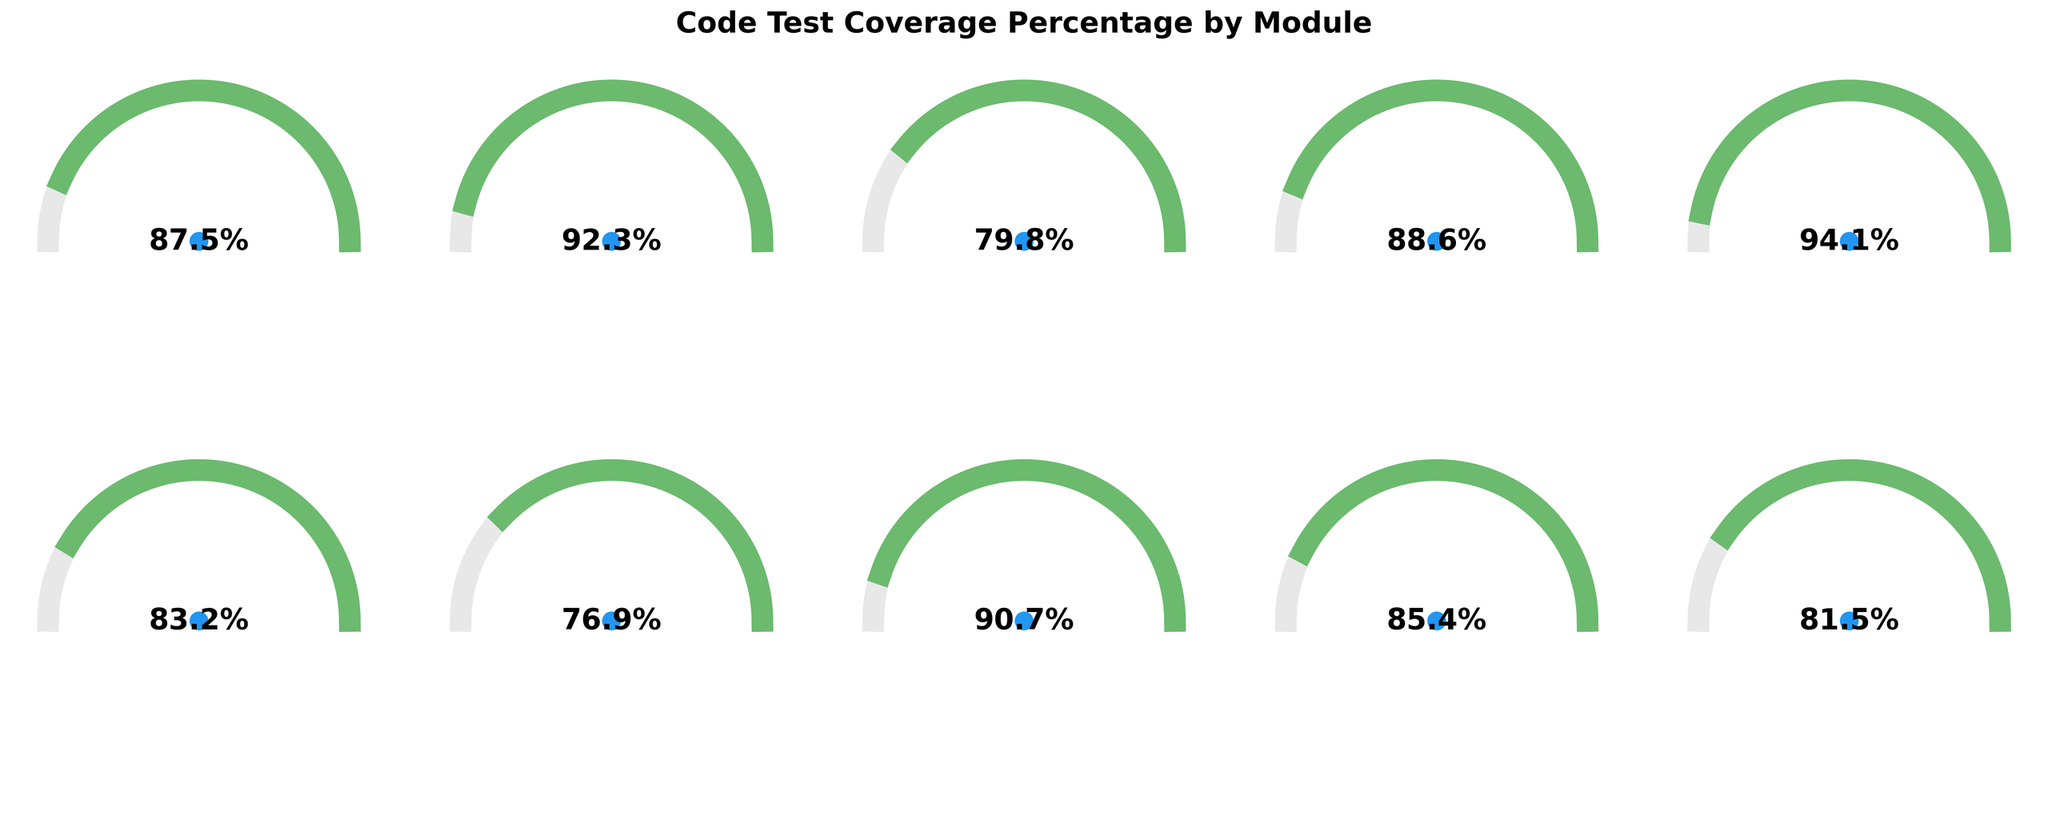What is the test coverage percentage for the Payment Processing module? Locate the "Payment Processing" gauge and read the percentage displayed in the center.
Answer: 94.1% Which module has the lowest test coverage percentage? Compare the percentages displayed at the centers of all gauges.
Answer: Search Functionality How many modules have a test coverage percentage greater than 90%? Count the gauges with percentages greater than 90%.
Answer: 4 What is the average test coverage percentage across all modules? Add up all the coverage percentages and divide by the number of modules. Specifically, (87.5 + 92.3 + 79.8 + 88.6 + 94.1 + 83.2 + 76.9 + 90.7 + 85.4 + 81.5) / 10 = 86%
Answer: 86% Which module shows a coverage percentage closest to 80%? Identify the module with a percentage closest to 80% by comparing the percentages.
Answer: Analytics Engine How much higher is the test coverage for the User Management module compared to the Notification Service module? Subtract the coverage percentage of the Notification Service module from the User Management module. Specifically, 92.3% - 83.2% = 9.1%
Answer: 9.1% Which modules have a coverage percentage between 80% and 90%? List all modules with a percentage within the specified range.
Answer: Authentication, Database Access Layer, Error Handling, Analytics Engine What is the median test coverage percentage across all modules? Sort the coverage percentages and find the middle value: (76.9, 79.8, 81.5, 83.2, 85.4, 87.5, 88.6, 90.7, 92.3, 94.1). With an even number of modules, the median is the average of the 5th and 6th values: (85.4 + 87.5) / 2 = 86.45
Answer: 86.45 Which module's gauge color indicates the highest test coverage percentage? Identify the module with the longest green (dark) segment in the gauge.
Answer: Payment Processing 